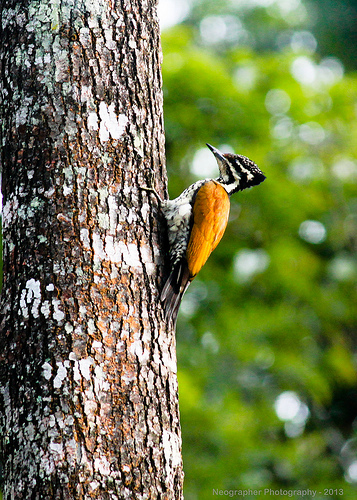Please provide a short description for this region: [0.47, 0.38, 0.52, 0.45]. This region showcases a patch of intricate feathers, likely part of the bird's wing, characterized by a mix of delicate white and brown tones facilitating insulation and flight. 